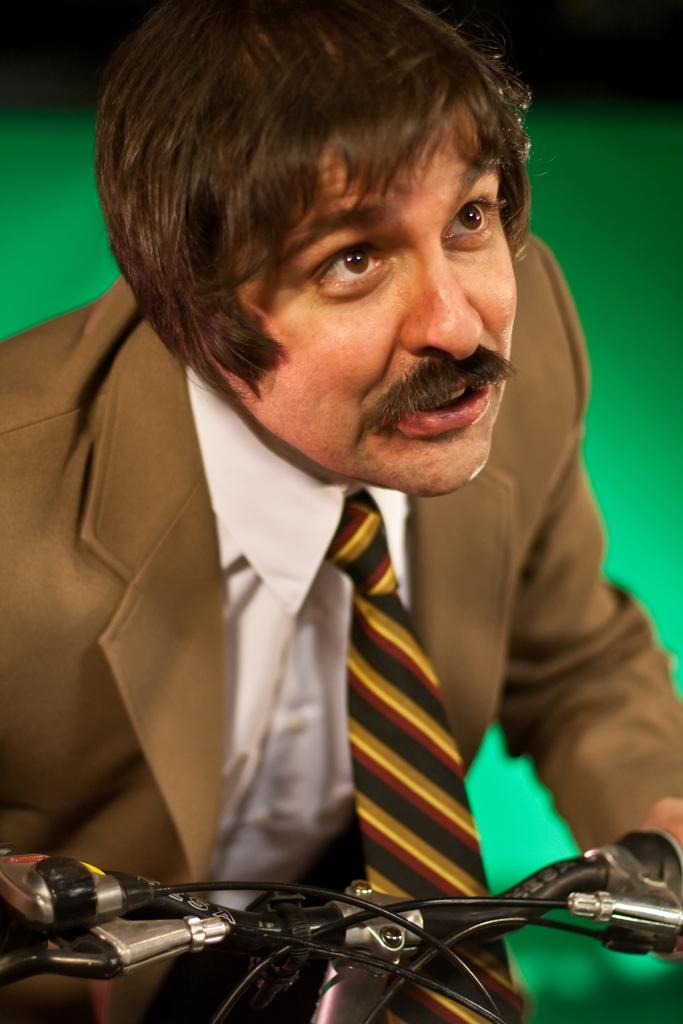Who is the main subject in the image? There is a man in the image. What is the man wearing? The man is wearing a suit. What activity is the man engaged in? The man is riding a bicycle. Who is the man looking at? The man is looking at someone. What type of pets does the man have in the image? There are no pets visible in the image. What color is the man's shirt in the image? The man is wearing a suit, not a shirt, in the image. 